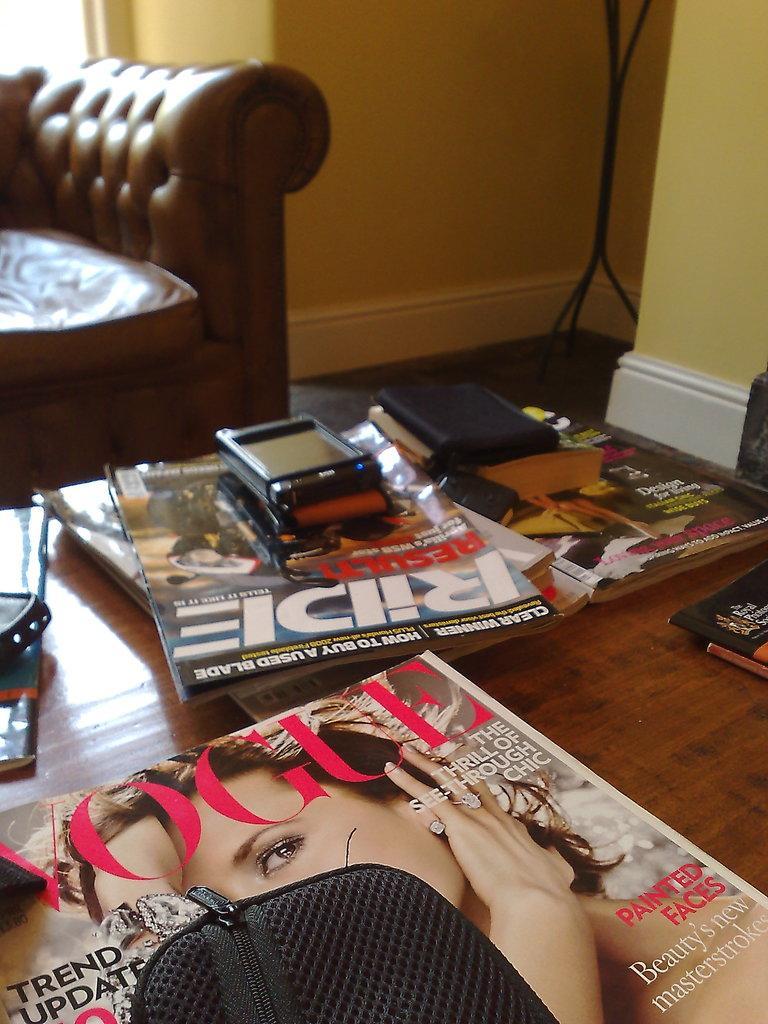Please provide a concise description of this image. On this table there are books, purse, and mobile. Far there is a couch in brown color. This wall is in yellow color. 